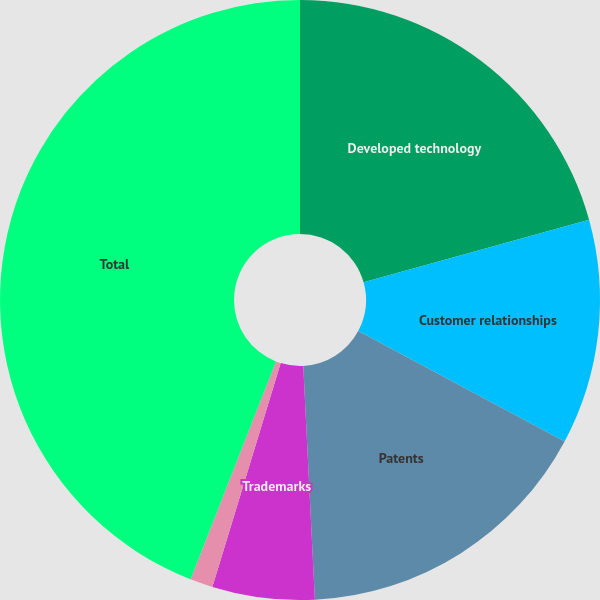<chart> <loc_0><loc_0><loc_500><loc_500><pie_chart><fcel>Developed technology<fcel>Customer relationships<fcel>Patents<fcel>Trademarks<fcel>Other<fcel>Total<nl><fcel>20.69%<fcel>12.12%<fcel>16.4%<fcel>5.51%<fcel>1.22%<fcel>44.06%<nl></chart> 